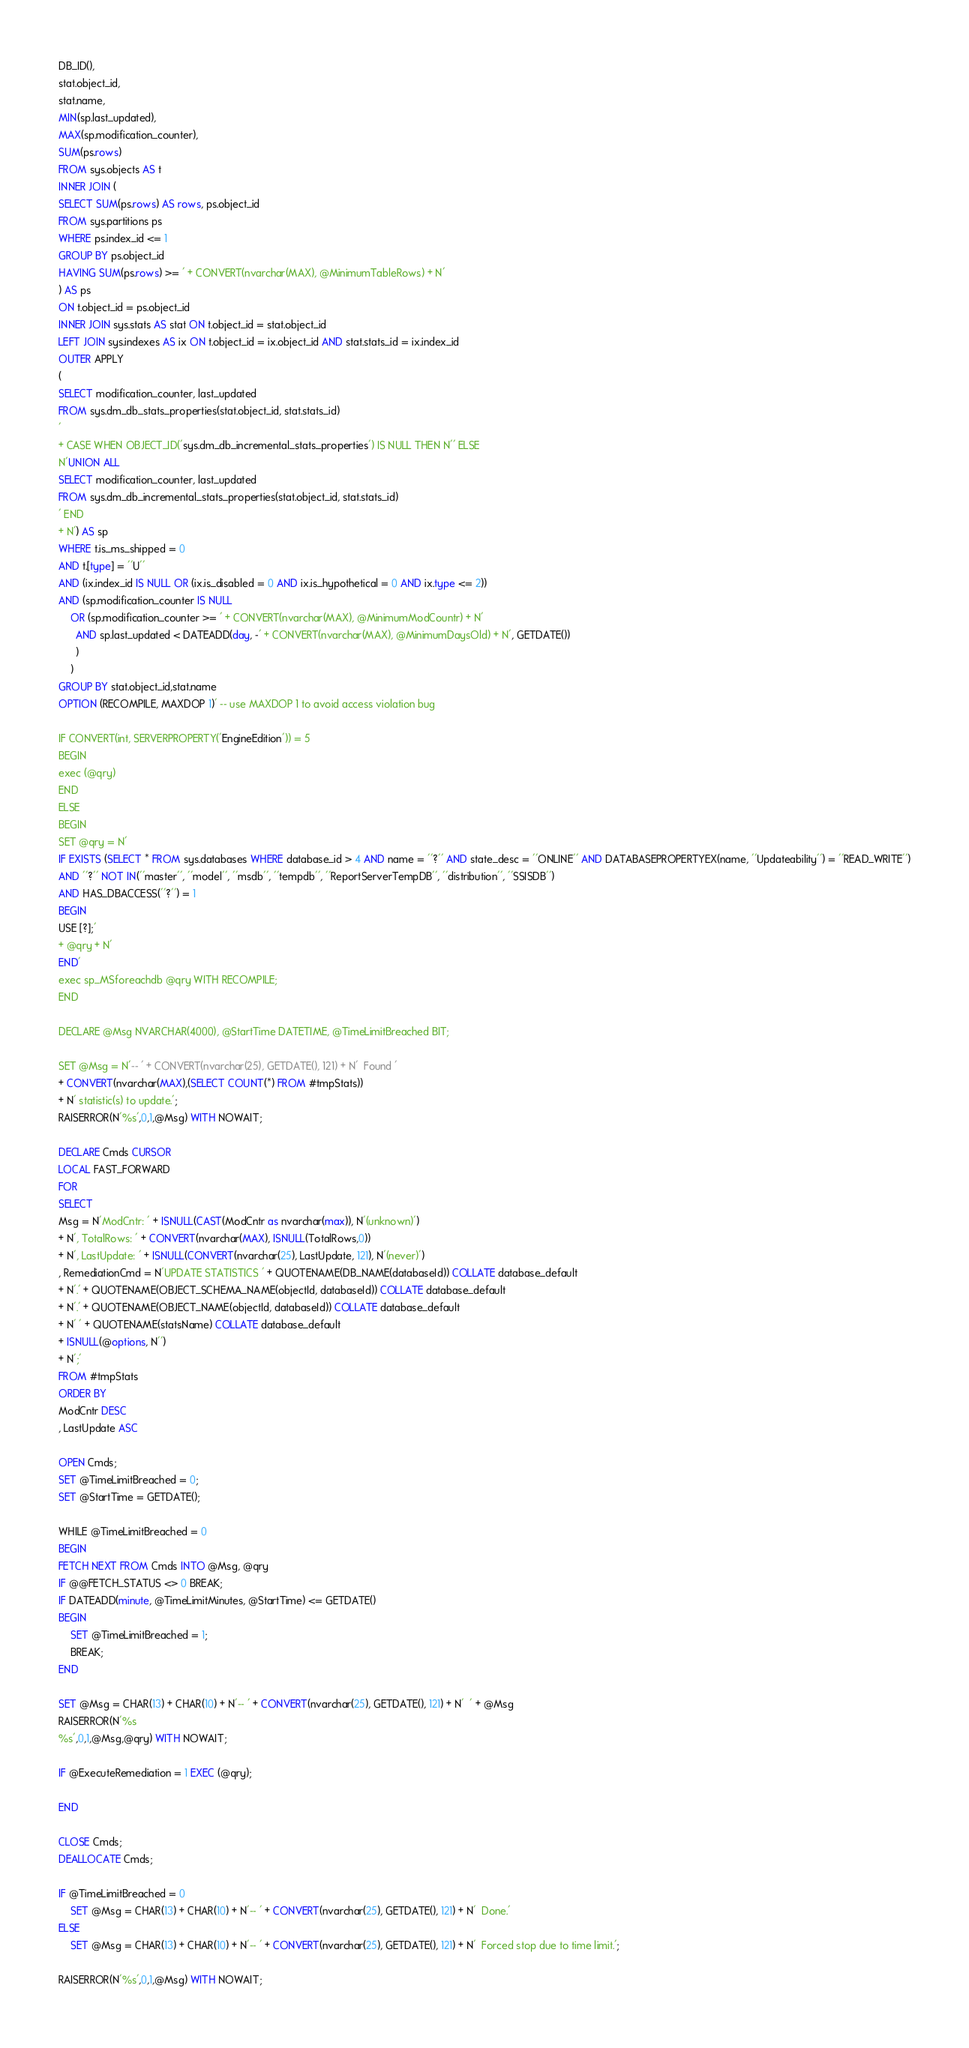<code> <loc_0><loc_0><loc_500><loc_500><_SQL_>DB_ID(),
stat.object_id,
stat.name,
MIN(sp.last_updated),
MAX(sp.modification_counter),
SUM(ps.rows)
FROM sys.objects AS t
INNER JOIN (
SELECT SUM(ps.rows) AS rows, ps.object_id
FROM sys.partitions ps 
WHERE ps.index_id <= 1 
GROUP BY ps.object_id
HAVING SUM(ps.rows) >= ' + CONVERT(nvarchar(MAX), @MinimumTableRows) + N'
) AS ps
ON t.object_id = ps.object_id 
INNER JOIN sys.stats AS stat ON t.object_id = stat.object_id
LEFT JOIN sys.indexes AS ix ON t.object_id = ix.object_id AND stat.stats_id = ix.index_id
OUTER APPLY
(
SELECT modification_counter, last_updated
FROM sys.dm_db_stats_properties(stat.object_id, stat.stats_id)
'
+ CASE WHEN OBJECT_ID('sys.dm_db_incremental_stats_properties') IS NULL THEN N'' ELSE 
N'UNION ALL
SELECT modification_counter, last_updated
FROM sys.dm_db_incremental_stats_properties(stat.object_id, stat.stats_id)
' END
+ N') AS sp
WHERE t.is_ms_shipped = 0
AND t.[type] = ''U''
AND (ix.index_id IS NULL OR (ix.is_disabled = 0 AND ix.is_hypothetical = 0 AND ix.type <= 2))
AND (sp.modification_counter IS NULL
	OR (sp.modification_counter >= ' + CONVERT(nvarchar(MAX), @MinimumModCountr) + N'
	  AND sp.last_updated < DATEADD(day, -' + CONVERT(nvarchar(MAX), @MinimumDaysOld) + N', GETDATE())
	  )
    )
GROUP BY stat.object_id,stat.name
OPTION (RECOMPILE, MAXDOP 1)' -- use MAXDOP 1 to avoid access violation bug

IF CONVERT(int, SERVERPROPERTY('EngineEdition')) = 5
BEGIN
exec (@qry)
END
ELSE
BEGIN
SET @qry = N'
IF EXISTS (SELECT * FROM sys.databases WHERE database_id > 4 AND name = ''?'' AND state_desc = ''ONLINE'' AND DATABASEPROPERTYEX(name, ''Updateability'') = ''READ_WRITE'')
AND ''?'' NOT IN(''master'', ''model'', ''msdb'', ''tempdb'', ''ReportServerTempDB'', ''distribution'', ''SSISDB'')
AND HAS_DBACCESS(''?'') = 1
BEGIN
USE [?];'
+ @qry + N'
END'
exec sp_MSforeachdb @qry WITH RECOMPILE;
END

DECLARE @Msg NVARCHAR(4000), @StartTime DATETIME, @TimeLimitBreached BIT;

SET @Msg = N'-- ' + CONVERT(nvarchar(25), GETDATE(), 121) + N'  Found '
+ CONVERT(nvarchar(MAX),(SELECT COUNT(*) FROM #tmpStats))
+ N' statistic(s) to update.';
RAISERROR(N'%s',0,1,@Msg) WITH NOWAIT;

DECLARE Cmds CURSOR
LOCAL FAST_FORWARD
FOR
SELECT
Msg = N'ModCntr: ' + ISNULL(CAST(ModCntr as nvarchar(max)), N'(unknown)')
+ N', TotalRows: ' + CONVERT(nvarchar(MAX), ISNULL(TotalRows,0))
+ N', LastUpdate: ' + ISNULL(CONVERT(nvarchar(25), LastUpdate, 121), N'(never)')
, RemediationCmd = N'UPDATE STATISTICS ' + QUOTENAME(DB_NAME(databaseId)) COLLATE database_default
+ N'.' + QUOTENAME(OBJECT_SCHEMA_NAME(objectId, databaseId)) COLLATE database_default
+ N'.' + QUOTENAME(OBJECT_NAME(objectId, databaseId)) COLLATE database_default
+ N' ' + QUOTENAME(statsName) COLLATE database_default
+ ISNULL(@options, N'')
+ N';'
FROM #tmpStats
ORDER BY
ModCntr DESC
, LastUpdate ASC

OPEN Cmds;
SET @TimeLimitBreached = 0;
SET @StartTime = GETDATE();

WHILE @TimeLimitBreached = 0
BEGIN
FETCH NEXT FROM Cmds INTO @Msg, @qry
IF @@FETCH_STATUS <> 0 BREAK;
IF DATEADD(minute, @TimeLimitMinutes, @StartTime) <= GETDATE()
BEGIN
	SET @TimeLimitBreached = 1;
	BREAK;
END

SET @Msg = CHAR(13) + CHAR(10) + N'-- ' + CONVERT(nvarchar(25), GETDATE(), 121) + N'  ' + @Msg
RAISERROR(N'%s
%s',0,1,@Msg,@qry) WITH NOWAIT;

IF @ExecuteRemediation = 1 EXEC (@qry);

END

CLOSE Cmds;
DEALLOCATE Cmds;

IF @TimeLimitBreached = 0
	SET @Msg = CHAR(13) + CHAR(10) + N'-- ' + CONVERT(nvarchar(25), GETDATE(), 121) + N'  Done.'
ELSE											      
	SET @Msg = CHAR(13) + CHAR(10) + N'-- ' + CONVERT(nvarchar(25), GETDATE(), 121) + N'  Forced stop due to time limit.';

RAISERROR(N'%s',0,1,@Msg) WITH NOWAIT;</code> 